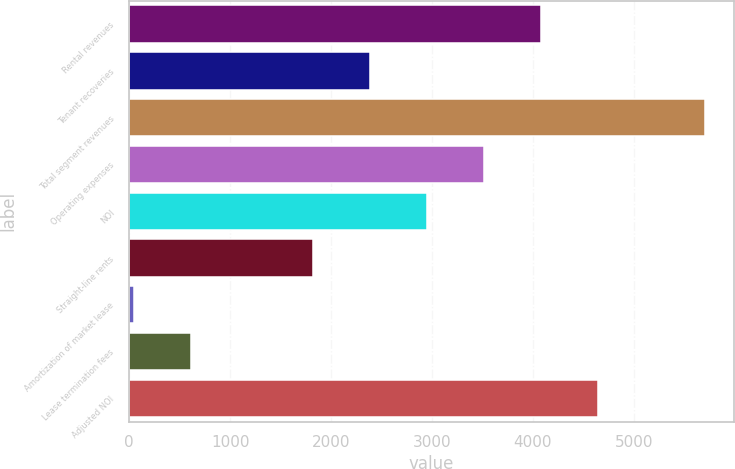Convert chart to OTSL. <chart><loc_0><loc_0><loc_500><loc_500><bar_chart><fcel>Rental revenues<fcel>Tenant recoveries<fcel>Total segment revenues<fcel>Operating expenses<fcel>NOI<fcel>Straight-line rents<fcel>Amortization of market lease<fcel>Lease termination fees<fcel>Adjusted NOI<nl><fcel>4080.8<fcel>2383.7<fcel>5702<fcel>3515.1<fcel>2949.4<fcel>1818<fcel>45<fcel>610.7<fcel>4646.5<nl></chart> 